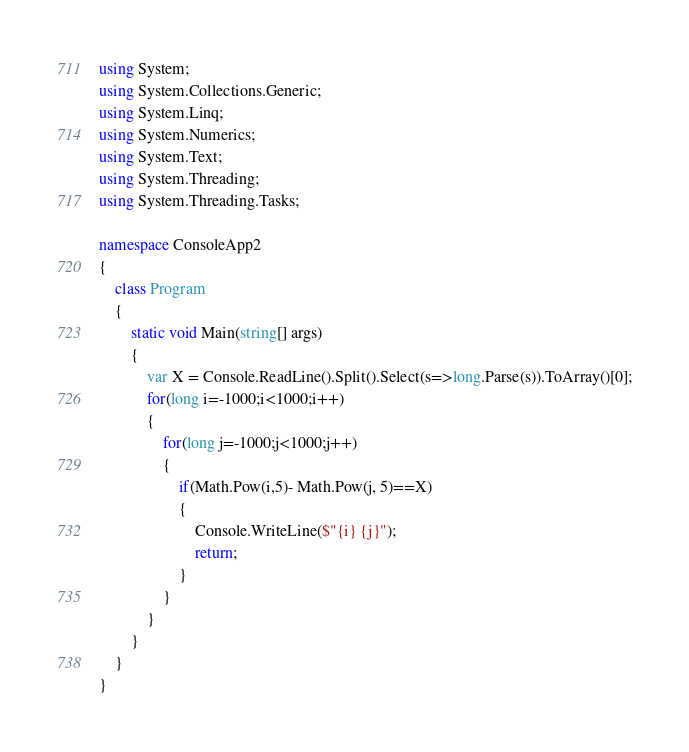Convert code to text. <code><loc_0><loc_0><loc_500><loc_500><_C#_>using System;
using System.Collections.Generic;
using System.Linq;
using System.Numerics;
using System.Text;
using System.Threading;
using System.Threading.Tasks;

namespace ConsoleApp2
{
    class Program
    {
        static void Main(string[] args)
        {
            var X = Console.ReadLine().Split().Select(s=>long.Parse(s)).ToArray()[0];
            for(long i=-1000;i<1000;i++)
            {
                for(long j=-1000;j<1000;j++)
                {
                    if(Math.Pow(i,5)- Math.Pow(j, 5)==X)
                    {
                        Console.WriteLine($"{i} {j}");
                        return;
                    }
                }
            }
        }
    }
}</code> 